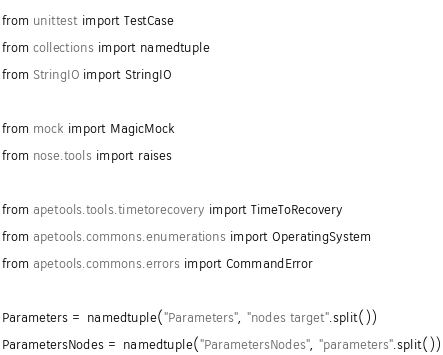<code> <loc_0><loc_0><loc_500><loc_500><_Python_>from unittest import TestCase
from collections import namedtuple
from StringIO import StringIO

from mock import MagicMock
from nose.tools import raises

from apetools.tools.timetorecovery import TimeToRecovery
from apetools.commons.enumerations import OperatingSystem
from apetools.commons.errors import CommandError

Parameters = namedtuple("Parameters", "nodes target".split())
ParametersNodes = namedtuple("ParametersNodes", "parameters".split())</code> 